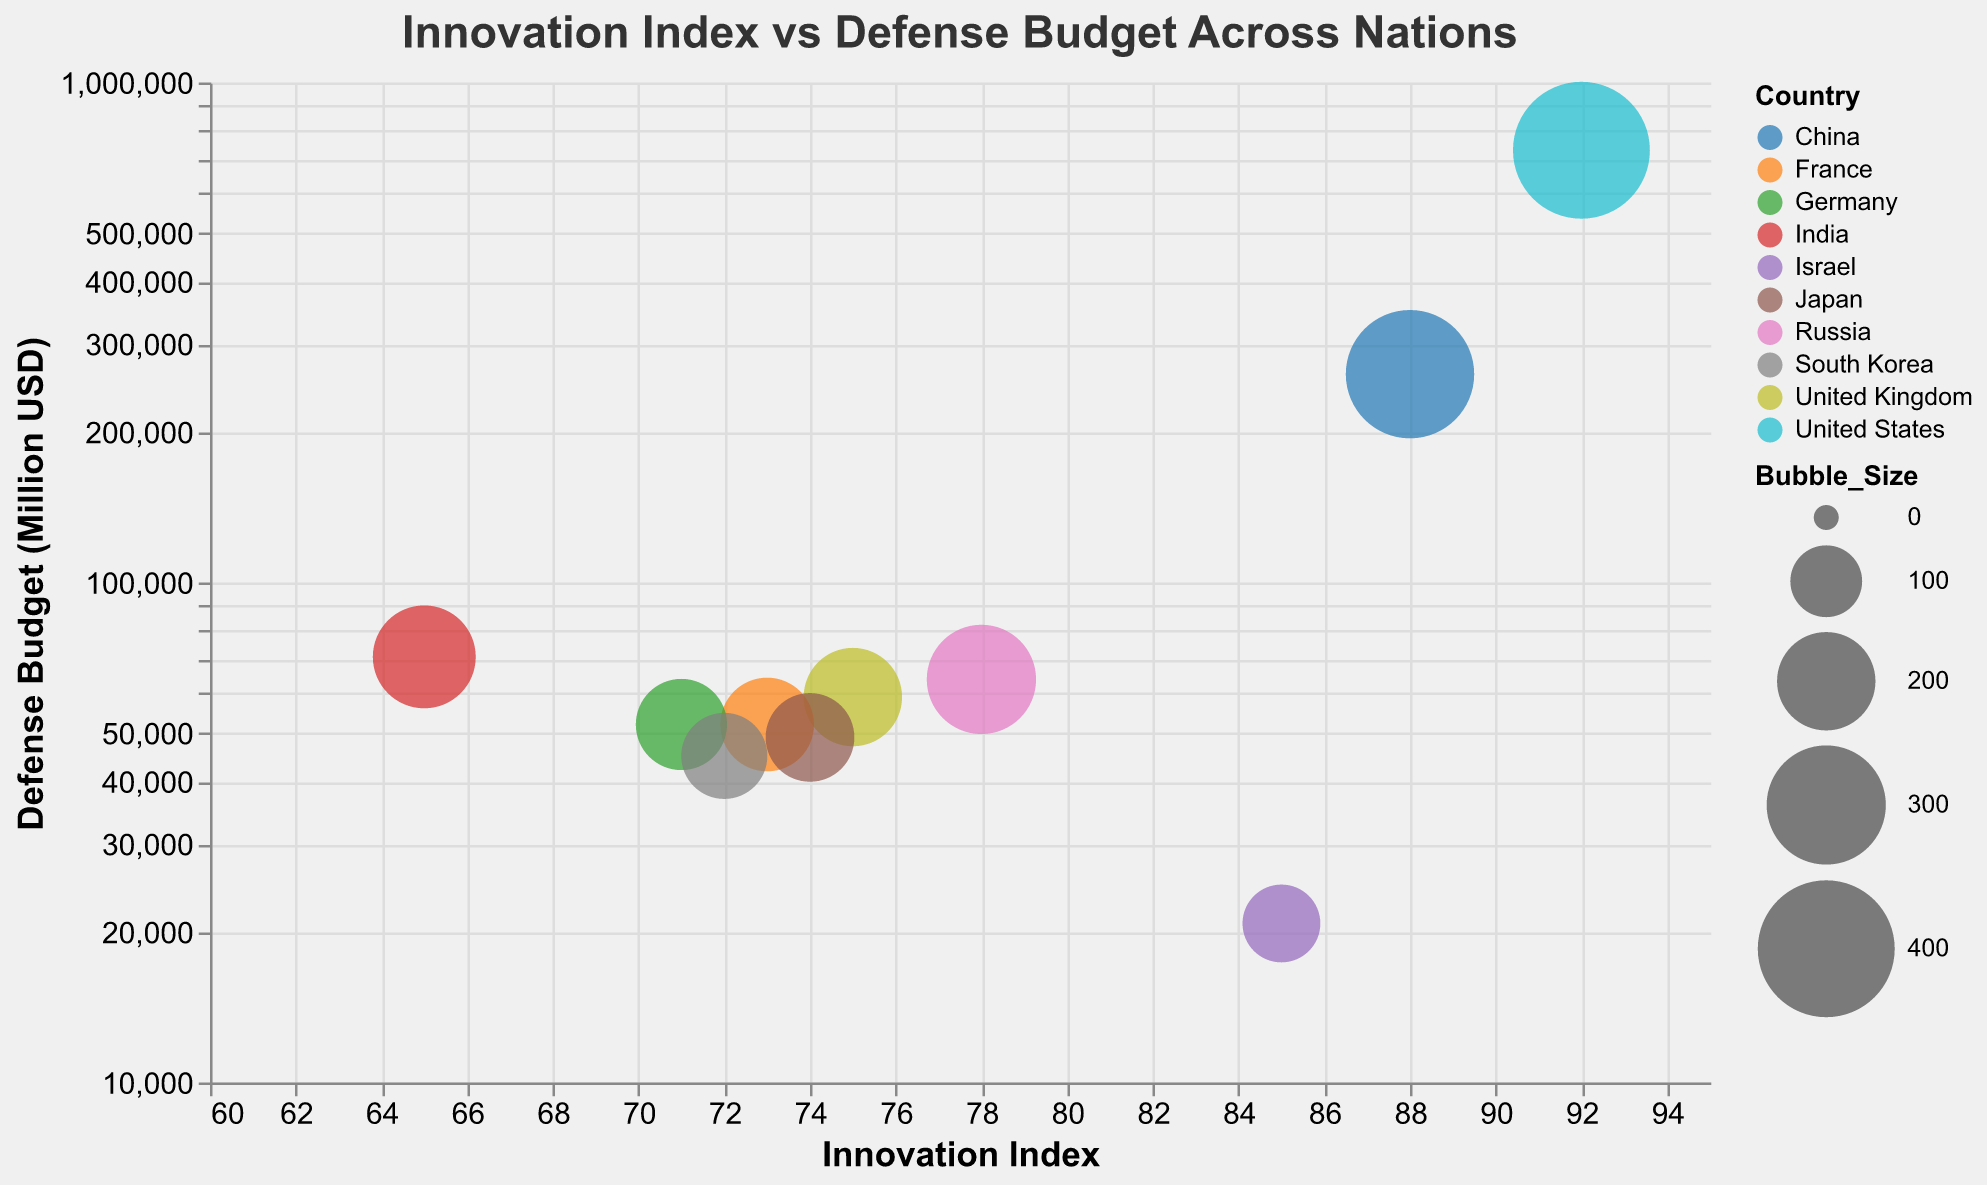What is the title of the chart? The title is located at the top of the chart. It reads "Innovation Index vs Defense Budget Across Nations".
Answer: Innovation Index vs Defense Budget Across Nations Which country has the highest Innovation Index? By observing the x-axis (Innovation Index) and the corresponding country names, the United States has the highest Innovation Index of 92.
Answer: United States Which country spends the most on defense according to the chart? By looking at the y-axis (Defense Budget), the United States has the highest defense budget of 732,000 million USD.
Answer: United States How many countries have an Innovation Index of 70 or higher? By counting the number of data points (countries) where the Innovation Index (x-axis) is 70 or higher, there are 8 countries: United States, China, Russia, United Kingdom, France, Germany, Israel, and Japan.
Answer: 8 Which country has the lowest defense budget? By observing the y-axis and the countries, Israel has the lowest defense budget of 20,800 million USD.
Answer: Israel What is the approximate difference between the defense budgets of the United States and China? The defense budget of the United States is 732,000 million USD, and that of China is 261,000 million USD. The difference is approximately 732,000 - 261,000 = 471,000 million USD.
Answer: 471,000 million USD Which country has the largest bubble size, and what does it represent? The United States has the largest bubble size, representing a value of 400. The bubble size could be indicative of relative importance or another significant metric.
Answer: United States Is there any country with a relatively high Innovation Index but a lower defense budget than others? Israel has a relatively high Innovation Index of 85 but a significantly lower defense budget of 20,800 million USD compared to other high Innovation Index countries.
Answer: Israel Between Germany and Japan, which country has a higher Innovation Index? By comparing the positions on the x-axis, Japan has an Innovation Index of 74, which is higher than Germany's 71.
Answer: Japan Do any two countries have the same defense budget but different Innovation Index values? France and Germany both have a defense budget of 52,000 million USD, but France's Innovation Index is 73 while Germany's is 71.
Answer: France and Germany 